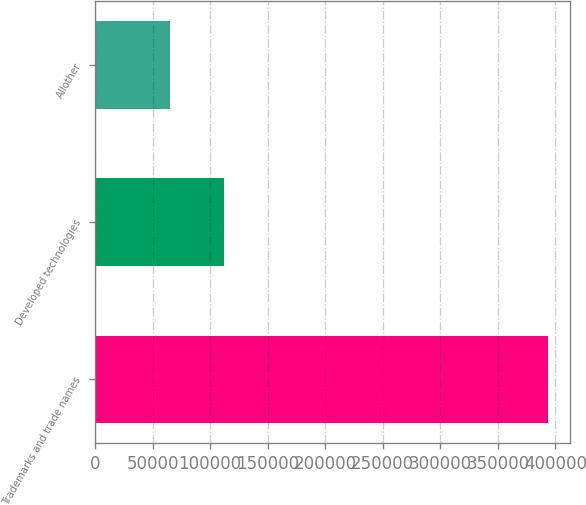Convert chart. <chart><loc_0><loc_0><loc_500><loc_500><bar_chart><fcel>Trademarks and trade names<fcel>Developed technologies<fcel>Allother<nl><fcel>393353<fcel>111973<fcel>64803<nl></chart> 